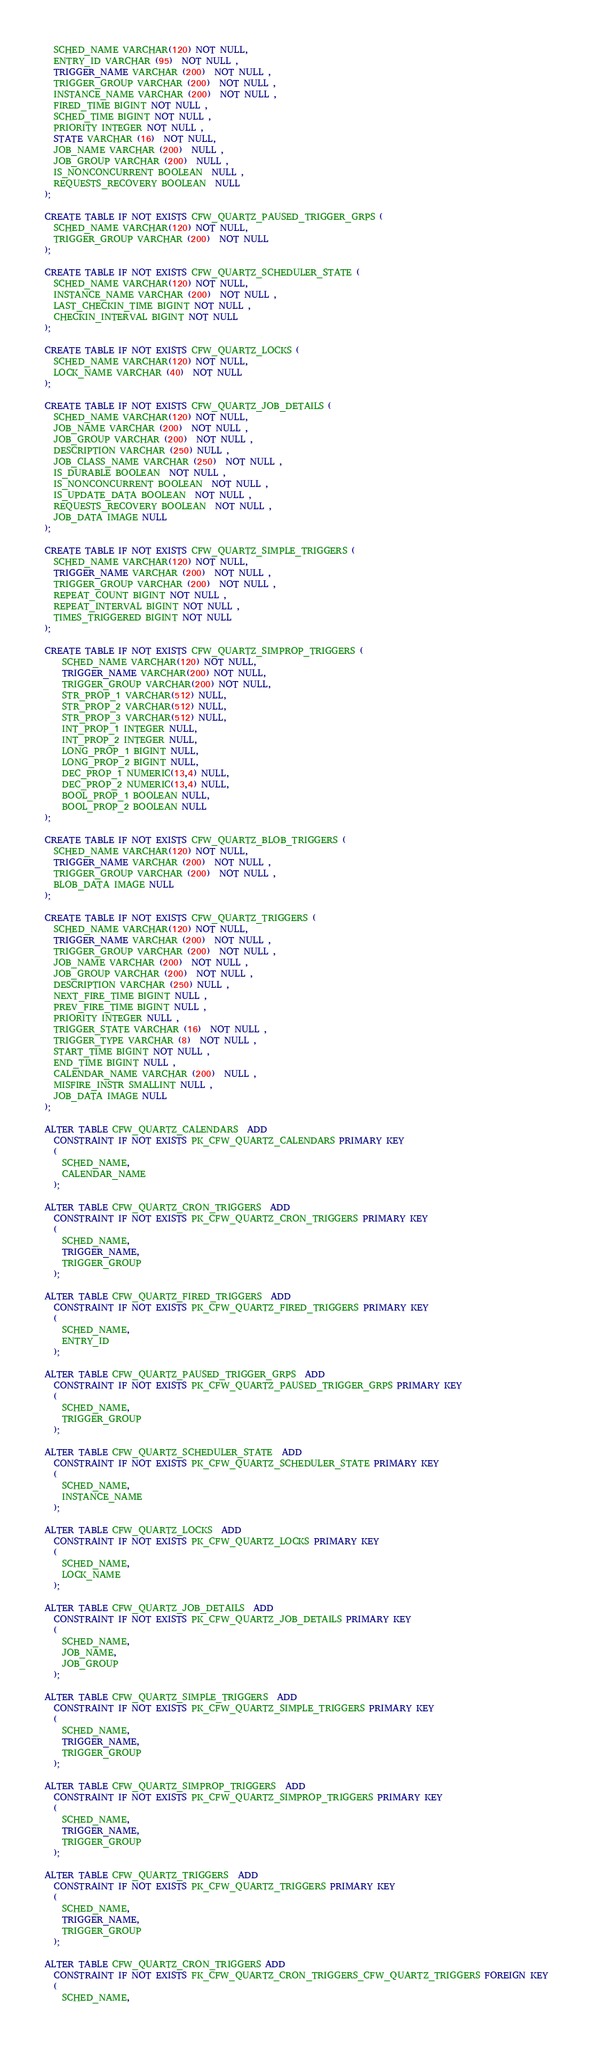<code> <loc_0><loc_0><loc_500><loc_500><_SQL_>  SCHED_NAME VARCHAR(120) NOT NULL,
  ENTRY_ID VARCHAR (95)  NOT NULL ,
  TRIGGER_NAME VARCHAR (200)  NOT NULL ,
  TRIGGER_GROUP VARCHAR (200)  NOT NULL ,
  INSTANCE_NAME VARCHAR (200)  NOT NULL ,
  FIRED_TIME BIGINT NOT NULL ,
  SCHED_TIME BIGINT NOT NULL ,
  PRIORITY INTEGER NOT NULL ,
  STATE VARCHAR (16)  NOT NULL,
  JOB_NAME VARCHAR (200)  NULL ,
  JOB_GROUP VARCHAR (200)  NULL ,
  IS_NONCONCURRENT BOOLEAN  NULL ,
  REQUESTS_RECOVERY BOOLEAN  NULL 
);

CREATE TABLE IF NOT EXISTS CFW_QUARTZ_PAUSED_TRIGGER_GRPS (
  SCHED_NAME VARCHAR(120) NOT NULL,
  TRIGGER_GROUP VARCHAR (200)  NOT NULL 
);

CREATE TABLE IF NOT EXISTS CFW_QUARTZ_SCHEDULER_STATE (
  SCHED_NAME VARCHAR(120) NOT NULL,
  INSTANCE_NAME VARCHAR (200)  NOT NULL ,
  LAST_CHECKIN_TIME BIGINT NOT NULL ,
  CHECKIN_INTERVAL BIGINT NOT NULL
);

CREATE TABLE IF NOT EXISTS CFW_QUARTZ_LOCKS (
  SCHED_NAME VARCHAR(120) NOT NULL,
  LOCK_NAME VARCHAR (40)  NOT NULL 
);

CREATE TABLE IF NOT EXISTS CFW_QUARTZ_JOB_DETAILS (
  SCHED_NAME VARCHAR(120) NOT NULL,
  JOB_NAME VARCHAR (200)  NOT NULL ,
  JOB_GROUP VARCHAR (200)  NOT NULL ,
  DESCRIPTION VARCHAR (250) NULL ,
  JOB_CLASS_NAME VARCHAR (250)  NOT NULL ,
  IS_DURABLE BOOLEAN  NOT NULL ,
  IS_NONCONCURRENT BOOLEAN  NOT NULL ,
  IS_UPDATE_DATA BOOLEAN  NOT NULL ,
  REQUESTS_RECOVERY BOOLEAN  NOT NULL ,
  JOB_DATA IMAGE NULL
);

CREATE TABLE IF NOT EXISTS CFW_QUARTZ_SIMPLE_TRIGGERS (
  SCHED_NAME VARCHAR(120) NOT NULL,
  TRIGGER_NAME VARCHAR (200)  NOT NULL ,
  TRIGGER_GROUP VARCHAR (200)  NOT NULL ,
  REPEAT_COUNT BIGINT NOT NULL ,
  REPEAT_INTERVAL BIGINT NOT NULL ,
  TIMES_TRIGGERED BIGINT NOT NULL
);

CREATE TABLE IF NOT EXISTS CFW_QUARTZ_SIMPROP_TRIGGERS (          
    SCHED_NAME VARCHAR(120) NOT NULL,
    TRIGGER_NAME VARCHAR(200) NOT NULL,
    TRIGGER_GROUP VARCHAR(200) NOT NULL,
    STR_PROP_1 VARCHAR(512) NULL,
    STR_PROP_2 VARCHAR(512) NULL,
    STR_PROP_3 VARCHAR(512) NULL,
    INT_PROP_1 INTEGER NULL,
    INT_PROP_2 INTEGER NULL,
    LONG_PROP_1 BIGINT NULL,
    LONG_PROP_2 BIGINT NULL,
    DEC_PROP_1 NUMERIC(13,4) NULL,
    DEC_PROP_2 NUMERIC(13,4) NULL,
    BOOL_PROP_1 BOOLEAN NULL,
    BOOL_PROP_2 BOOLEAN NULL
);

CREATE TABLE IF NOT EXISTS CFW_QUARTZ_BLOB_TRIGGERS (
  SCHED_NAME VARCHAR(120) NOT NULL,
  TRIGGER_NAME VARCHAR (200)  NOT NULL ,
  TRIGGER_GROUP VARCHAR (200)  NOT NULL ,
  BLOB_DATA IMAGE NULL
);

CREATE TABLE IF NOT EXISTS CFW_QUARTZ_TRIGGERS (
  SCHED_NAME VARCHAR(120) NOT NULL,
  TRIGGER_NAME VARCHAR (200)  NOT NULL ,
  TRIGGER_GROUP VARCHAR (200)  NOT NULL ,
  JOB_NAME VARCHAR (200)  NOT NULL ,
  JOB_GROUP VARCHAR (200)  NOT NULL ,
  DESCRIPTION VARCHAR (250) NULL ,
  NEXT_FIRE_TIME BIGINT NULL ,
  PREV_FIRE_TIME BIGINT NULL ,
  PRIORITY INTEGER NULL ,
  TRIGGER_STATE VARCHAR (16)  NOT NULL ,
  TRIGGER_TYPE VARCHAR (8)  NOT NULL ,
  START_TIME BIGINT NOT NULL ,
  END_TIME BIGINT NULL ,
  CALENDAR_NAME VARCHAR (200)  NULL ,
  MISFIRE_INSTR SMALLINT NULL ,
  JOB_DATA IMAGE NULL
);

ALTER TABLE CFW_QUARTZ_CALENDARS  ADD
  CONSTRAINT IF NOT EXISTS PK_CFW_QUARTZ_CALENDARS PRIMARY KEY  
  (
    SCHED_NAME,
    CALENDAR_NAME
  );

ALTER TABLE CFW_QUARTZ_CRON_TRIGGERS  ADD
  CONSTRAINT IF NOT EXISTS PK_CFW_QUARTZ_CRON_TRIGGERS PRIMARY KEY  
  (
    SCHED_NAME,
    TRIGGER_NAME,
    TRIGGER_GROUP
  );

ALTER TABLE CFW_QUARTZ_FIRED_TRIGGERS  ADD
  CONSTRAINT IF NOT EXISTS PK_CFW_QUARTZ_FIRED_TRIGGERS PRIMARY KEY  
  (
    SCHED_NAME,
    ENTRY_ID
  );

ALTER TABLE CFW_QUARTZ_PAUSED_TRIGGER_GRPS  ADD
  CONSTRAINT IF NOT EXISTS PK_CFW_QUARTZ_PAUSED_TRIGGER_GRPS PRIMARY KEY  
  (
    SCHED_NAME,
    TRIGGER_GROUP
  );

ALTER TABLE CFW_QUARTZ_SCHEDULER_STATE  ADD
  CONSTRAINT IF NOT EXISTS PK_CFW_QUARTZ_SCHEDULER_STATE PRIMARY KEY  
  (
    SCHED_NAME,
    INSTANCE_NAME
  );

ALTER TABLE CFW_QUARTZ_LOCKS  ADD
  CONSTRAINT IF NOT EXISTS PK_CFW_QUARTZ_LOCKS PRIMARY KEY  
  (
    SCHED_NAME,
    LOCK_NAME
  );

ALTER TABLE CFW_QUARTZ_JOB_DETAILS  ADD
  CONSTRAINT IF NOT EXISTS PK_CFW_QUARTZ_JOB_DETAILS PRIMARY KEY  
  (
    SCHED_NAME,
    JOB_NAME,
    JOB_GROUP
  );

ALTER TABLE CFW_QUARTZ_SIMPLE_TRIGGERS  ADD
  CONSTRAINT IF NOT EXISTS PK_CFW_QUARTZ_SIMPLE_TRIGGERS PRIMARY KEY  
  (
    SCHED_NAME,
    TRIGGER_NAME,
    TRIGGER_GROUP
  );

ALTER TABLE CFW_QUARTZ_SIMPROP_TRIGGERS  ADD
  CONSTRAINT IF NOT EXISTS PK_CFW_QUARTZ_SIMPROP_TRIGGERS PRIMARY KEY  
  (
    SCHED_NAME,
    TRIGGER_NAME,
    TRIGGER_GROUP
  );

ALTER TABLE CFW_QUARTZ_TRIGGERS  ADD
  CONSTRAINT IF NOT EXISTS PK_CFW_QUARTZ_TRIGGERS PRIMARY KEY  
  (
    SCHED_NAME,
    TRIGGER_NAME,
    TRIGGER_GROUP
  );

ALTER TABLE CFW_QUARTZ_CRON_TRIGGERS ADD
  CONSTRAINT IF NOT EXISTS FK_CFW_QUARTZ_CRON_TRIGGERS_CFW_QUARTZ_TRIGGERS FOREIGN KEY
  (
    SCHED_NAME,</code> 